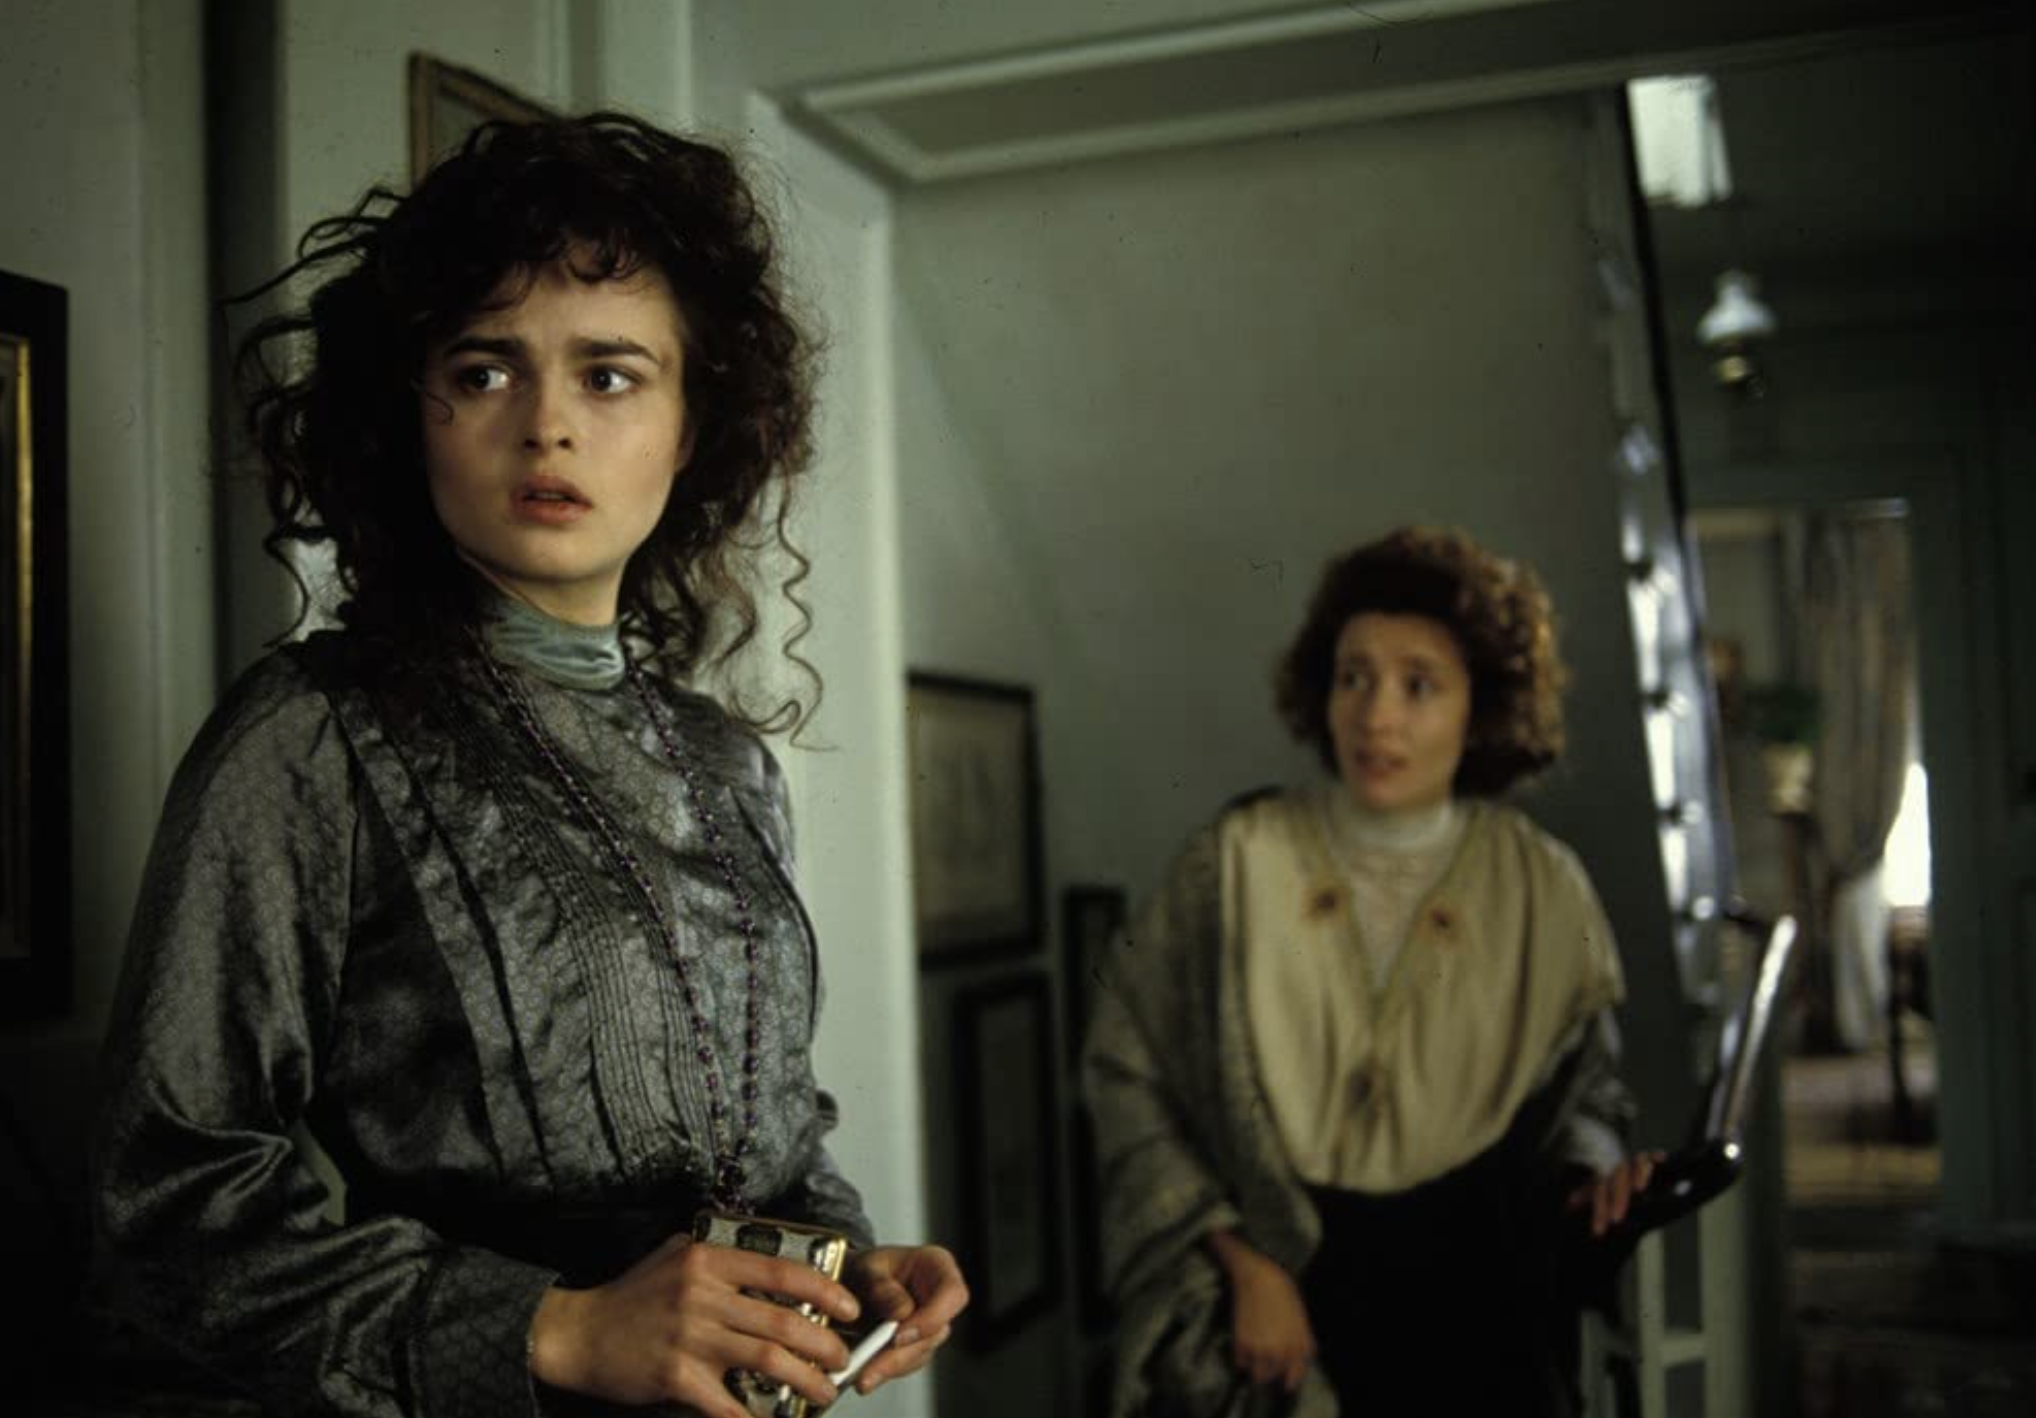How might this scene transition if it were part of a stage play rather than a film? In a stage play, this scene would likely transition with carefully coordinated lighting changes to reflect the emotional shifts. Spotlights might focus on Lucy and Charlotte to highlight their expressions and movements, drawing the audience's attention to the intensity of their interaction. To signal a transition, the lights might dim gradually as the characters exit, or a background change could occur swiftly to indicate a shift to a different setting, helping to maintain the flow of the narrative without losing emotional momentum. If the characters in the image could speak directly to the audience, breaking the fourth wall, what might they say? Lucy might step forward and address the audience with a heartfelt plea, 'You see me standing here, uncertain of my future. You have watched my journey, felt my doubts and fears. Tell me, dear audience, what would you do in my place? Would you follow the heart, or yield to the expectations that bind us?' Meanwhile, Charlotte might interject with a stern reminder, 'Remember, it is not only our lives we must consider, but the legacy we leave behind. Traditions are not easily cast aside, nor should they be…' 